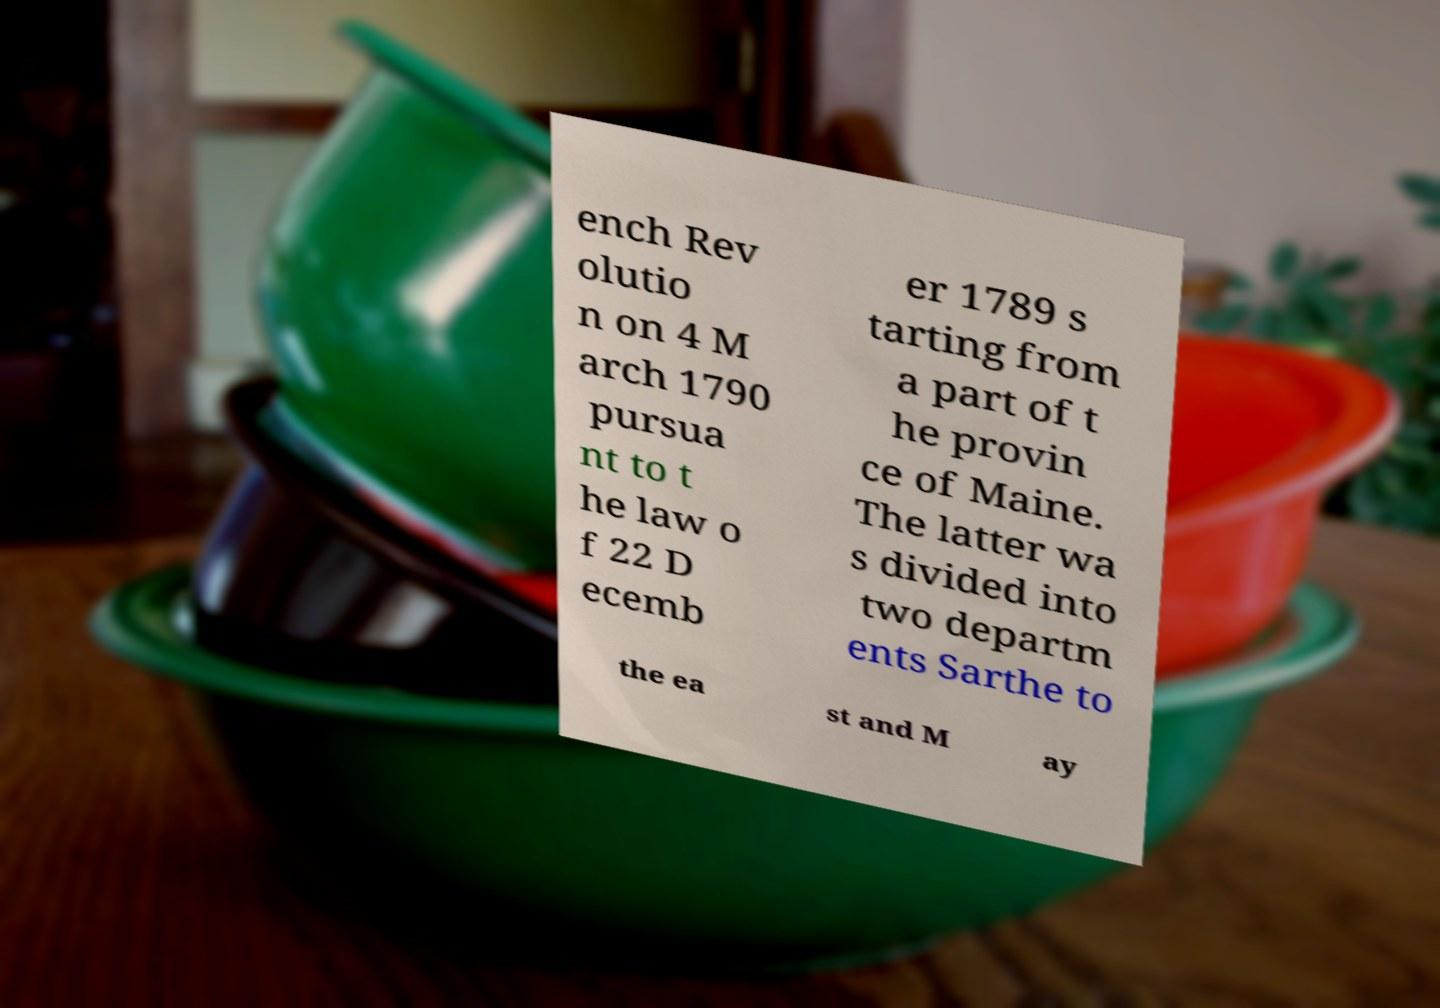Please identify and transcribe the text found in this image. ench Rev olutio n on 4 M arch 1790 pursua nt to t he law o f 22 D ecemb er 1789 s tarting from a part of t he provin ce of Maine. The latter wa s divided into two departm ents Sarthe to the ea st and M ay 